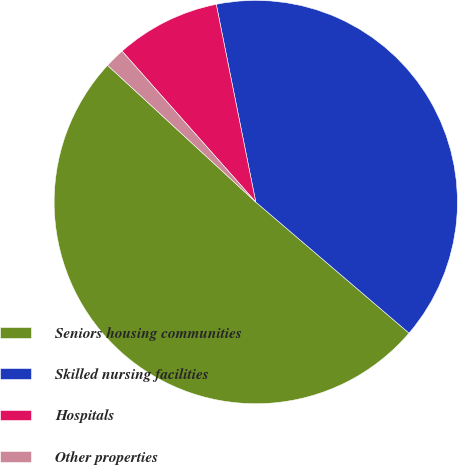Convert chart to OTSL. <chart><loc_0><loc_0><loc_500><loc_500><pie_chart><fcel>Seniors housing communities<fcel>Skilled nursing facilities<fcel>Hospitals<fcel>Other properties<nl><fcel>50.6%<fcel>39.4%<fcel>8.4%<fcel>1.6%<nl></chart> 